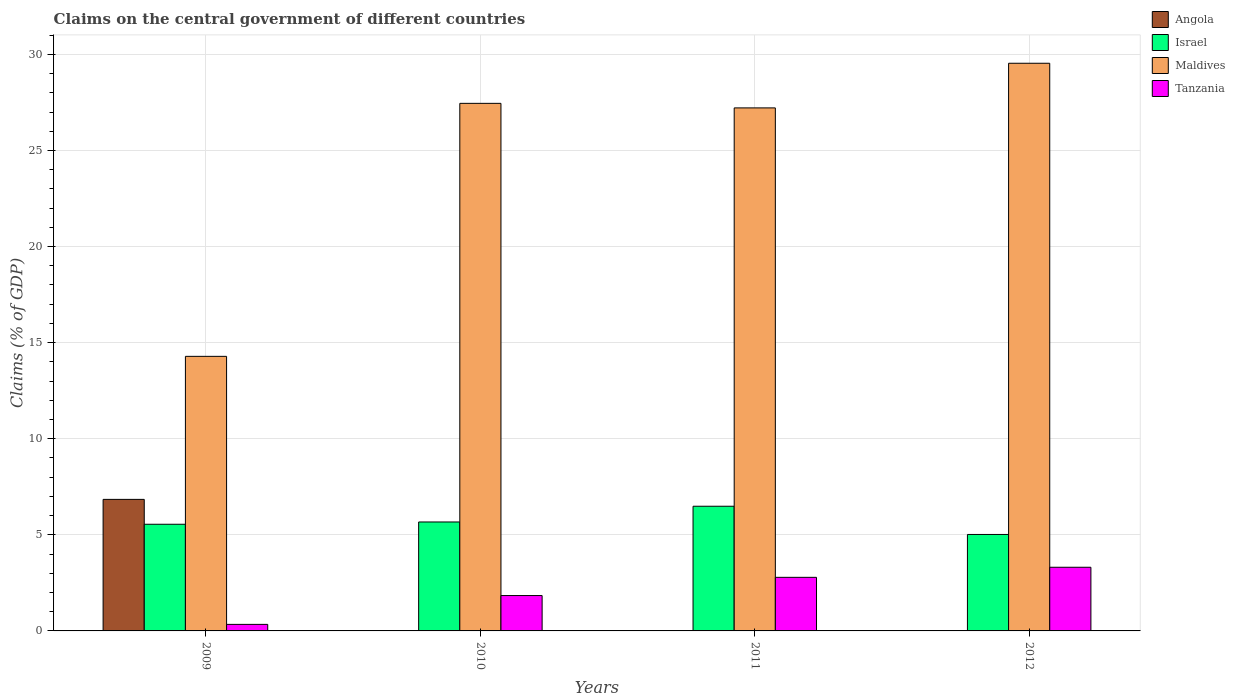How many different coloured bars are there?
Your answer should be very brief. 4. Are the number of bars per tick equal to the number of legend labels?
Your response must be concise. No. How many bars are there on the 2nd tick from the right?
Your answer should be very brief. 3. What is the percentage of GDP claimed on the central government in Israel in 2010?
Your response must be concise. 5.67. Across all years, what is the maximum percentage of GDP claimed on the central government in Angola?
Keep it short and to the point. 6.84. In which year was the percentage of GDP claimed on the central government in Israel maximum?
Your answer should be compact. 2011. What is the total percentage of GDP claimed on the central government in Angola in the graph?
Give a very brief answer. 6.84. What is the difference between the percentage of GDP claimed on the central government in Israel in 2009 and that in 2012?
Offer a very short reply. 0.53. What is the difference between the percentage of GDP claimed on the central government in Tanzania in 2011 and the percentage of GDP claimed on the central government in Maldives in 2012?
Your answer should be very brief. -26.75. What is the average percentage of GDP claimed on the central government in Maldives per year?
Provide a succinct answer. 24.62. In the year 2011, what is the difference between the percentage of GDP claimed on the central government in Israel and percentage of GDP claimed on the central government in Maldives?
Give a very brief answer. -20.73. In how many years, is the percentage of GDP claimed on the central government in Angola greater than 20 %?
Your response must be concise. 0. What is the ratio of the percentage of GDP claimed on the central government in Maldives in 2011 to that in 2012?
Offer a terse response. 0.92. Is the difference between the percentage of GDP claimed on the central government in Israel in 2010 and 2011 greater than the difference between the percentage of GDP claimed on the central government in Maldives in 2010 and 2011?
Provide a succinct answer. No. What is the difference between the highest and the second highest percentage of GDP claimed on the central government in Maldives?
Make the answer very short. 2.09. What is the difference between the highest and the lowest percentage of GDP claimed on the central government in Israel?
Provide a short and direct response. 1.47. In how many years, is the percentage of GDP claimed on the central government in Maldives greater than the average percentage of GDP claimed on the central government in Maldives taken over all years?
Offer a very short reply. 3. Is it the case that in every year, the sum of the percentage of GDP claimed on the central government in Israel and percentage of GDP claimed on the central government in Angola is greater than the sum of percentage of GDP claimed on the central government in Maldives and percentage of GDP claimed on the central government in Tanzania?
Provide a short and direct response. No. Are all the bars in the graph horizontal?
Give a very brief answer. No. Are the values on the major ticks of Y-axis written in scientific E-notation?
Ensure brevity in your answer.  No. Does the graph contain grids?
Keep it short and to the point. Yes. Where does the legend appear in the graph?
Provide a succinct answer. Top right. How many legend labels are there?
Your response must be concise. 4. What is the title of the graph?
Keep it short and to the point. Claims on the central government of different countries. Does "Singapore" appear as one of the legend labels in the graph?
Your response must be concise. No. What is the label or title of the X-axis?
Provide a succinct answer. Years. What is the label or title of the Y-axis?
Offer a very short reply. Claims (% of GDP). What is the Claims (% of GDP) in Angola in 2009?
Provide a succinct answer. 6.84. What is the Claims (% of GDP) of Israel in 2009?
Give a very brief answer. 5.55. What is the Claims (% of GDP) of Maldives in 2009?
Your response must be concise. 14.29. What is the Claims (% of GDP) in Tanzania in 2009?
Keep it short and to the point. 0.34. What is the Claims (% of GDP) of Israel in 2010?
Offer a terse response. 5.67. What is the Claims (% of GDP) in Maldives in 2010?
Provide a succinct answer. 27.45. What is the Claims (% of GDP) of Tanzania in 2010?
Ensure brevity in your answer.  1.84. What is the Claims (% of GDP) of Angola in 2011?
Offer a very short reply. 0. What is the Claims (% of GDP) of Israel in 2011?
Keep it short and to the point. 6.49. What is the Claims (% of GDP) of Maldives in 2011?
Provide a succinct answer. 27.22. What is the Claims (% of GDP) of Tanzania in 2011?
Offer a terse response. 2.79. What is the Claims (% of GDP) in Angola in 2012?
Keep it short and to the point. 0. What is the Claims (% of GDP) in Israel in 2012?
Provide a short and direct response. 5.02. What is the Claims (% of GDP) of Maldives in 2012?
Make the answer very short. 29.54. What is the Claims (% of GDP) of Tanzania in 2012?
Ensure brevity in your answer.  3.31. Across all years, what is the maximum Claims (% of GDP) of Angola?
Your answer should be very brief. 6.84. Across all years, what is the maximum Claims (% of GDP) of Israel?
Provide a succinct answer. 6.49. Across all years, what is the maximum Claims (% of GDP) of Maldives?
Make the answer very short. 29.54. Across all years, what is the maximum Claims (% of GDP) of Tanzania?
Offer a very short reply. 3.31. Across all years, what is the minimum Claims (% of GDP) in Israel?
Give a very brief answer. 5.02. Across all years, what is the minimum Claims (% of GDP) of Maldives?
Offer a very short reply. 14.29. Across all years, what is the minimum Claims (% of GDP) of Tanzania?
Ensure brevity in your answer.  0.34. What is the total Claims (% of GDP) of Angola in the graph?
Offer a very short reply. 6.84. What is the total Claims (% of GDP) of Israel in the graph?
Provide a short and direct response. 22.73. What is the total Claims (% of GDP) of Maldives in the graph?
Your answer should be compact. 98.49. What is the total Claims (% of GDP) of Tanzania in the graph?
Offer a terse response. 8.28. What is the difference between the Claims (% of GDP) of Israel in 2009 and that in 2010?
Your answer should be very brief. -0.12. What is the difference between the Claims (% of GDP) of Maldives in 2009 and that in 2010?
Give a very brief answer. -13.16. What is the difference between the Claims (% of GDP) in Tanzania in 2009 and that in 2010?
Ensure brevity in your answer.  -1.5. What is the difference between the Claims (% of GDP) of Israel in 2009 and that in 2011?
Your answer should be very brief. -0.94. What is the difference between the Claims (% of GDP) in Maldives in 2009 and that in 2011?
Your answer should be very brief. -12.93. What is the difference between the Claims (% of GDP) of Tanzania in 2009 and that in 2011?
Your response must be concise. -2.45. What is the difference between the Claims (% of GDP) of Israel in 2009 and that in 2012?
Give a very brief answer. 0.53. What is the difference between the Claims (% of GDP) in Maldives in 2009 and that in 2012?
Offer a very short reply. -15.25. What is the difference between the Claims (% of GDP) in Tanzania in 2009 and that in 2012?
Your answer should be very brief. -2.97. What is the difference between the Claims (% of GDP) of Israel in 2010 and that in 2011?
Keep it short and to the point. -0.82. What is the difference between the Claims (% of GDP) of Maldives in 2010 and that in 2011?
Provide a succinct answer. 0.24. What is the difference between the Claims (% of GDP) in Tanzania in 2010 and that in 2011?
Keep it short and to the point. -0.95. What is the difference between the Claims (% of GDP) of Israel in 2010 and that in 2012?
Provide a short and direct response. 0.65. What is the difference between the Claims (% of GDP) in Maldives in 2010 and that in 2012?
Provide a succinct answer. -2.09. What is the difference between the Claims (% of GDP) of Tanzania in 2010 and that in 2012?
Provide a succinct answer. -1.47. What is the difference between the Claims (% of GDP) of Israel in 2011 and that in 2012?
Offer a terse response. 1.47. What is the difference between the Claims (% of GDP) of Maldives in 2011 and that in 2012?
Keep it short and to the point. -2.32. What is the difference between the Claims (% of GDP) in Tanzania in 2011 and that in 2012?
Keep it short and to the point. -0.52. What is the difference between the Claims (% of GDP) in Angola in 2009 and the Claims (% of GDP) in Israel in 2010?
Provide a short and direct response. 1.18. What is the difference between the Claims (% of GDP) in Angola in 2009 and the Claims (% of GDP) in Maldives in 2010?
Provide a succinct answer. -20.61. What is the difference between the Claims (% of GDP) in Angola in 2009 and the Claims (% of GDP) in Tanzania in 2010?
Make the answer very short. 5. What is the difference between the Claims (% of GDP) in Israel in 2009 and the Claims (% of GDP) in Maldives in 2010?
Provide a short and direct response. -21.9. What is the difference between the Claims (% of GDP) in Israel in 2009 and the Claims (% of GDP) in Tanzania in 2010?
Ensure brevity in your answer.  3.71. What is the difference between the Claims (% of GDP) in Maldives in 2009 and the Claims (% of GDP) in Tanzania in 2010?
Your response must be concise. 12.45. What is the difference between the Claims (% of GDP) of Angola in 2009 and the Claims (% of GDP) of Israel in 2011?
Your answer should be compact. 0.36. What is the difference between the Claims (% of GDP) in Angola in 2009 and the Claims (% of GDP) in Maldives in 2011?
Provide a short and direct response. -20.37. What is the difference between the Claims (% of GDP) in Angola in 2009 and the Claims (% of GDP) in Tanzania in 2011?
Offer a terse response. 4.06. What is the difference between the Claims (% of GDP) in Israel in 2009 and the Claims (% of GDP) in Maldives in 2011?
Your answer should be very brief. -21.66. What is the difference between the Claims (% of GDP) of Israel in 2009 and the Claims (% of GDP) of Tanzania in 2011?
Provide a short and direct response. 2.76. What is the difference between the Claims (% of GDP) of Maldives in 2009 and the Claims (% of GDP) of Tanzania in 2011?
Provide a succinct answer. 11.5. What is the difference between the Claims (% of GDP) of Angola in 2009 and the Claims (% of GDP) of Israel in 2012?
Your answer should be very brief. 1.83. What is the difference between the Claims (% of GDP) of Angola in 2009 and the Claims (% of GDP) of Maldives in 2012?
Ensure brevity in your answer.  -22.69. What is the difference between the Claims (% of GDP) of Angola in 2009 and the Claims (% of GDP) of Tanzania in 2012?
Keep it short and to the point. 3.53. What is the difference between the Claims (% of GDP) of Israel in 2009 and the Claims (% of GDP) of Maldives in 2012?
Offer a very short reply. -23.99. What is the difference between the Claims (% of GDP) of Israel in 2009 and the Claims (% of GDP) of Tanzania in 2012?
Make the answer very short. 2.24. What is the difference between the Claims (% of GDP) of Maldives in 2009 and the Claims (% of GDP) of Tanzania in 2012?
Ensure brevity in your answer.  10.97. What is the difference between the Claims (% of GDP) of Israel in 2010 and the Claims (% of GDP) of Maldives in 2011?
Make the answer very short. -21.55. What is the difference between the Claims (% of GDP) in Israel in 2010 and the Claims (% of GDP) in Tanzania in 2011?
Provide a succinct answer. 2.88. What is the difference between the Claims (% of GDP) in Maldives in 2010 and the Claims (% of GDP) in Tanzania in 2011?
Your answer should be very brief. 24.66. What is the difference between the Claims (% of GDP) in Israel in 2010 and the Claims (% of GDP) in Maldives in 2012?
Your answer should be very brief. -23.87. What is the difference between the Claims (% of GDP) in Israel in 2010 and the Claims (% of GDP) in Tanzania in 2012?
Give a very brief answer. 2.36. What is the difference between the Claims (% of GDP) of Maldives in 2010 and the Claims (% of GDP) of Tanzania in 2012?
Give a very brief answer. 24.14. What is the difference between the Claims (% of GDP) of Israel in 2011 and the Claims (% of GDP) of Maldives in 2012?
Your answer should be very brief. -23.05. What is the difference between the Claims (% of GDP) in Israel in 2011 and the Claims (% of GDP) in Tanzania in 2012?
Keep it short and to the point. 3.17. What is the difference between the Claims (% of GDP) in Maldives in 2011 and the Claims (% of GDP) in Tanzania in 2012?
Make the answer very short. 23.9. What is the average Claims (% of GDP) of Angola per year?
Give a very brief answer. 1.71. What is the average Claims (% of GDP) of Israel per year?
Offer a very short reply. 5.68. What is the average Claims (% of GDP) of Maldives per year?
Ensure brevity in your answer.  24.62. What is the average Claims (% of GDP) of Tanzania per year?
Make the answer very short. 2.07. In the year 2009, what is the difference between the Claims (% of GDP) in Angola and Claims (% of GDP) in Israel?
Provide a succinct answer. 1.29. In the year 2009, what is the difference between the Claims (% of GDP) in Angola and Claims (% of GDP) in Maldives?
Ensure brevity in your answer.  -7.44. In the year 2009, what is the difference between the Claims (% of GDP) in Angola and Claims (% of GDP) in Tanzania?
Ensure brevity in your answer.  6.5. In the year 2009, what is the difference between the Claims (% of GDP) of Israel and Claims (% of GDP) of Maldives?
Your answer should be very brief. -8.74. In the year 2009, what is the difference between the Claims (% of GDP) in Israel and Claims (% of GDP) in Tanzania?
Offer a terse response. 5.21. In the year 2009, what is the difference between the Claims (% of GDP) of Maldives and Claims (% of GDP) of Tanzania?
Provide a succinct answer. 13.95. In the year 2010, what is the difference between the Claims (% of GDP) of Israel and Claims (% of GDP) of Maldives?
Give a very brief answer. -21.78. In the year 2010, what is the difference between the Claims (% of GDP) of Israel and Claims (% of GDP) of Tanzania?
Your response must be concise. 3.83. In the year 2010, what is the difference between the Claims (% of GDP) of Maldives and Claims (% of GDP) of Tanzania?
Your answer should be very brief. 25.61. In the year 2011, what is the difference between the Claims (% of GDP) in Israel and Claims (% of GDP) in Maldives?
Your answer should be very brief. -20.73. In the year 2011, what is the difference between the Claims (% of GDP) of Israel and Claims (% of GDP) of Tanzania?
Your response must be concise. 3.7. In the year 2011, what is the difference between the Claims (% of GDP) in Maldives and Claims (% of GDP) in Tanzania?
Your answer should be compact. 24.43. In the year 2012, what is the difference between the Claims (% of GDP) of Israel and Claims (% of GDP) of Maldives?
Ensure brevity in your answer.  -24.52. In the year 2012, what is the difference between the Claims (% of GDP) of Israel and Claims (% of GDP) of Tanzania?
Ensure brevity in your answer.  1.71. In the year 2012, what is the difference between the Claims (% of GDP) of Maldives and Claims (% of GDP) of Tanzania?
Your answer should be very brief. 26.23. What is the ratio of the Claims (% of GDP) of Israel in 2009 to that in 2010?
Give a very brief answer. 0.98. What is the ratio of the Claims (% of GDP) in Maldives in 2009 to that in 2010?
Offer a terse response. 0.52. What is the ratio of the Claims (% of GDP) in Tanzania in 2009 to that in 2010?
Keep it short and to the point. 0.18. What is the ratio of the Claims (% of GDP) of Israel in 2009 to that in 2011?
Your answer should be very brief. 0.86. What is the ratio of the Claims (% of GDP) of Maldives in 2009 to that in 2011?
Make the answer very short. 0.53. What is the ratio of the Claims (% of GDP) in Tanzania in 2009 to that in 2011?
Make the answer very short. 0.12. What is the ratio of the Claims (% of GDP) of Israel in 2009 to that in 2012?
Give a very brief answer. 1.11. What is the ratio of the Claims (% of GDP) of Maldives in 2009 to that in 2012?
Provide a succinct answer. 0.48. What is the ratio of the Claims (% of GDP) in Tanzania in 2009 to that in 2012?
Make the answer very short. 0.1. What is the ratio of the Claims (% of GDP) in Israel in 2010 to that in 2011?
Provide a short and direct response. 0.87. What is the ratio of the Claims (% of GDP) of Maldives in 2010 to that in 2011?
Offer a very short reply. 1.01. What is the ratio of the Claims (% of GDP) of Tanzania in 2010 to that in 2011?
Your answer should be compact. 0.66. What is the ratio of the Claims (% of GDP) of Israel in 2010 to that in 2012?
Offer a very short reply. 1.13. What is the ratio of the Claims (% of GDP) of Maldives in 2010 to that in 2012?
Offer a very short reply. 0.93. What is the ratio of the Claims (% of GDP) of Tanzania in 2010 to that in 2012?
Provide a short and direct response. 0.56. What is the ratio of the Claims (% of GDP) in Israel in 2011 to that in 2012?
Provide a short and direct response. 1.29. What is the ratio of the Claims (% of GDP) of Maldives in 2011 to that in 2012?
Keep it short and to the point. 0.92. What is the ratio of the Claims (% of GDP) of Tanzania in 2011 to that in 2012?
Offer a very short reply. 0.84. What is the difference between the highest and the second highest Claims (% of GDP) of Israel?
Make the answer very short. 0.82. What is the difference between the highest and the second highest Claims (% of GDP) in Maldives?
Make the answer very short. 2.09. What is the difference between the highest and the second highest Claims (% of GDP) in Tanzania?
Your answer should be very brief. 0.52. What is the difference between the highest and the lowest Claims (% of GDP) of Angola?
Keep it short and to the point. 6.84. What is the difference between the highest and the lowest Claims (% of GDP) in Israel?
Your answer should be very brief. 1.47. What is the difference between the highest and the lowest Claims (% of GDP) of Maldives?
Offer a very short reply. 15.25. What is the difference between the highest and the lowest Claims (% of GDP) of Tanzania?
Ensure brevity in your answer.  2.97. 